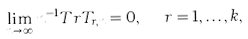Convert formula to latex. <formula><loc_0><loc_0><loc_500><loc_500>\lim _ { n \rightarrow \infty } n ^ { - 1 } T r T _ { r , n } = 0 , \ \ r = 1 , \dots , k ,</formula> 